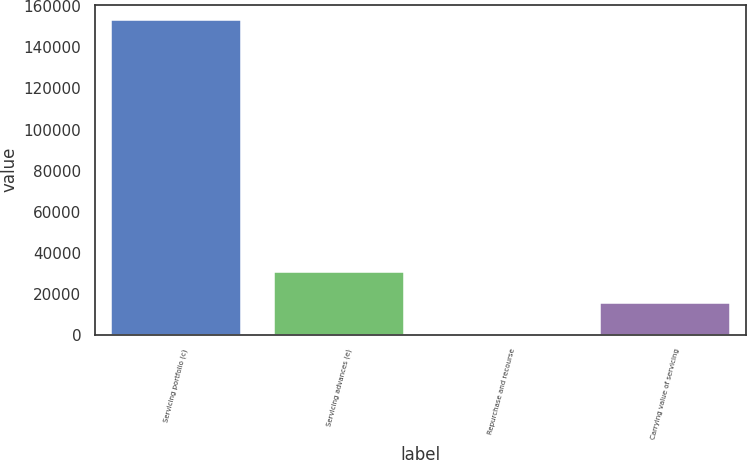<chart> <loc_0><loc_0><loc_500><loc_500><bar_chart><fcel>Servicing portfolio (c)<fcel>Servicing advances (e)<fcel>Repurchase and recourse<fcel>Carrying value of servicing<nl><fcel>153193<fcel>30673<fcel>43<fcel>15358<nl></chart> 